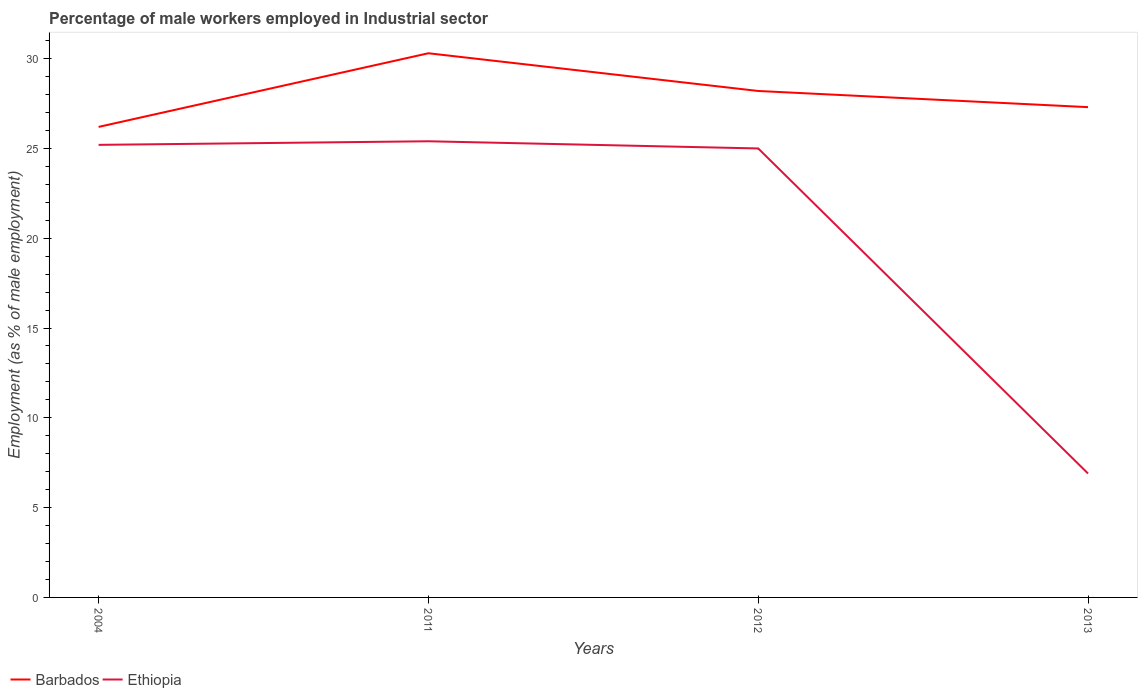How many different coloured lines are there?
Make the answer very short. 2. Does the line corresponding to Barbados intersect with the line corresponding to Ethiopia?
Give a very brief answer. No. Is the number of lines equal to the number of legend labels?
Offer a terse response. Yes. Across all years, what is the maximum percentage of male workers employed in Industrial sector in Barbados?
Your answer should be very brief. 26.2. In which year was the percentage of male workers employed in Industrial sector in Ethiopia maximum?
Give a very brief answer. 2013. What is the total percentage of male workers employed in Industrial sector in Barbados in the graph?
Ensure brevity in your answer.  -1.1. What is the difference between the highest and the second highest percentage of male workers employed in Industrial sector in Ethiopia?
Your answer should be very brief. 18.5. Is the percentage of male workers employed in Industrial sector in Barbados strictly greater than the percentage of male workers employed in Industrial sector in Ethiopia over the years?
Give a very brief answer. No. What is the difference between two consecutive major ticks on the Y-axis?
Your answer should be compact. 5. Are the values on the major ticks of Y-axis written in scientific E-notation?
Make the answer very short. No. Does the graph contain grids?
Offer a terse response. No. Where does the legend appear in the graph?
Offer a very short reply. Bottom left. How many legend labels are there?
Make the answer very short. 2. How are the legend labels stacked?
Provide a succinct answer. Horizontal. What is the title of the graph?
Provide a short and direct response. Percentage of male workers employed in Industrial sector. What is the label or title of the Y-axis?
Your answer should be very brief. Employment (as % of male employment). What is the Employment (as % of male employment) in Barbados in 2004?
Give a very brief answer. 26.2. What is the Employment (as % of male employment) of Ethiopia in 2004?
Your answer should be compact. 25.2. What is the Employment (as % of male employment) of Barbados in 2011?
Your response must be concise. 30.3. What is the Employment (as % of male employment) of Ethiopia in 2011?
Your answer should be very brief. 25.4. What is the Employment (as % of male employment) of Barbados in 2012?
Offer a very short reply. 28.2. What is the Employment (as % of male employment) of Ethiopia in 2012?
Offer a very short reply. 25. What is the Employment (as % of male employment) in Barbados in 2013?
Make the answer very short. 27.3. What is the Employment (as % of male employment) in Ethiopia in 2013?
Give a very brief answer. 6.9. Across all years, what is the maximum Employment (as % of male employment) of Barbados?
Your response must be concise. 30.3. Across all years, what is the maximum Employment (as % of male employment) in Ethiopia?
Give a very brief answer. 25.4. Across all years, what is the minimum Employment (as % of male employment) in Barbados?
Give a very brief answer. 26.2. Across all years, what is the minimum Employment (as % of male employment) of Ethiopia?
Give a very brief answer. 6.9. What is the total Employment (as % of male employment) of Barbados in the graph?
Offer a very short reply. 112. What is the total Employment (as % of male employment) in Ethiopia in the graph?
Provide a short and direct response. 82.5. What is the difference between the Employment (as % of male employment) of Barbados in 2004 and that in 2011?
Offer a very short reply. -4.1. What is the difference between the Employment (as % of male employment) of Ethiopia in 2004 and that in 2013?
Your response must be concise. 18.3. What is the difference between the Employment (as % of male employment) of Barbados in 2011 and that in 2012?
Give a very brief answer. 2.1. What is the difference between the Employment (as % of male employment) of Ethiopia in 2011 and that in 2012?
Ensure brevity in your answer.  0.4. What is the difference between the Employment (as % of male employment) of Barbados in 2011 and that in 2013?
Provide a succinct answer. 3. What is the difference between the Employment (as % of male employment) in Barbados in 2012 and that in 2013?
Your answer should be compact. 0.9. What is the difference between the Employment (as % of male employment) in Barbados in 2004 and the Employment (as % of male employment) in Ethiopia in 2011?
Your answer should be very brief. 0.8. What is the difference between the Employment (as % of male employment) in Barbados in 2004 and the Employment (as % of male employment) in Ethiopia in 2013?
Give a very brief answer. 19.3. What is the difference between the Employment (as % of male employment) of Barbados in 2011 and the Employment (as % of male employment) of Ethiopia in 2012?
Offer a very short reply. 5.3. What is the difference between the Employment (as % of male employment) of Barbados in 2011 and the Employment (as % of male employment) of Ethiopia in 2013?
Your answer should be very brief. 23.4. What is the difference between the Employment (as % of male employment) of Barbados in 2012 and the Employment (as % of male employment) of Ethiopia in 2013?
Offer a terse response. 21.3. What is the average Employment (as % of male employment) of Ethiopia per year?
Give a very brief answer. 20.62. In the year 2004, what is the difference between the Employment (as % of male employment) of Barbados and Employment (as % of male employment) of Ethiopia?
Your answer should be very brief. 1. In the year 2013, what is the difference between the Employment (as % of male employment) in Barbados and Employment (as % of male employment) in Ethiopia?
Your answer should be very brief. 20.4. What is the ratio of the Employment (as % of male employment) in Barbados in 2004 to that in 2011?
Your answer should be compact. 0.86. What is the ratio of the Employment (as % of male employment) in Barbados in 2004 to that in 2012?
Offer a terse response. 0.93. What is the ratio of the Employment (as % of male employment) in Ethiopia in 2004 to that in 2012?
Offer a terse response. 1.01. What is the ratio of the Employment (as % of male employment) of Barbados in 2004 to that in 2013?
Ensure brevity in your answer.  0.96. What is the ratio of the Employment (as % of male employment) in Ethiopia in 2004 to that in 2013?
Make the answer very short. 3.65. What is the ratio of the Employment (as % of male employment) in Barbados in 2011 to that in 2012?
Offer a very short reply. 1.07. What is the ratio of the Employment (as % of male employment) of Ethiopia in 2011 to that in 2012?
Your response must be concise. 1.02. What is the ratio of the Employment (as % of male employment) of Barbados in 2011 to that in 2013?
Provide a short and direct response. 1.11. What is the ratio of the Employment (as % of male employment) in Ethiopia in 2011 to that in 2013?
Make the answer very short. 3.68. What is the ratio of the Employment (as % of male employment) in Barbados in 2012 to that in 2013?
Ensure brevity in your answer.  1.03. What is the ratio of the Employment (as % of male employment) of Ethiopia in 2012 to that in 2013?
Make the answer very short. 3.62. What is the difference between the highest and the second highest Employment (as % of male employment) in Barbados?
Ensure brevity in your answer.  2.1. What is the difference between the highest and the second highest Employment (as % of male employment) of Ethiopia?
Provide a succinct answer. 0.2. 